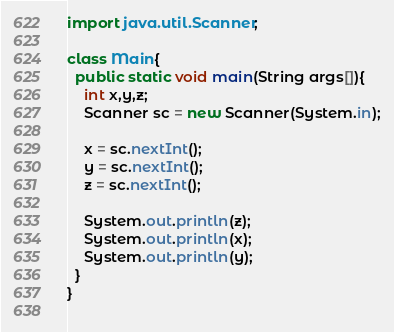Convert code to text. <code><loc_0><loc_0><loc_500><loc_500><_Java_>import java.util.Scanner;

class Main{
  public static void main(String args[]){
    int x,y,z;
    Scanner sc = new Scanner(System.in);
    
    x = sc.nextInt();
    y = sc.nextInt();
    z = sc.nextInt();
    
    System.out.println(z);
    System.out.println(x);
    System.out.println(y);
  }
}
    </code> 